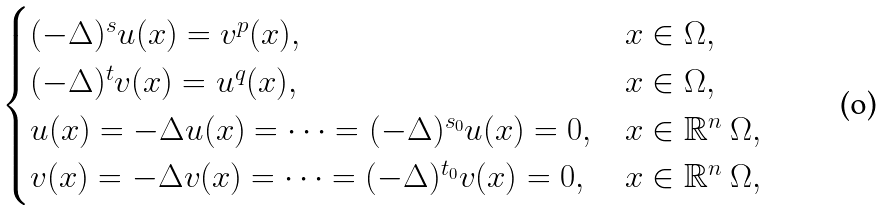Convert formula to latex. <formula><loc_0><loc_0><loc_500><loc_500>\begin{cases} ( - \Delta ) ^ { s } u ( x ) = v ^ { p } ( x ) , & x \in \Omega , \\ ( - \Delta ) ^ { t } v ( x ) = u ^ { q } ( x ) , & x \in \Omega , \\ u ( x ) = - \Delta u ( x ) = \cdots = ( - \Delta ) ^ { s _ { 0 } } u ( x ) = 0 , & x \in \mathbb { R } ^ { n } \ \Omega , \\ v ( x ) = - \Delta v ( x ) = \cdots = ( - \Delta ) ^ { t _ { 0 } } v ( x ) = 0 , & x \in \mathbb { R } ^ { n } \ \Omega , \end{cases}</formula> 